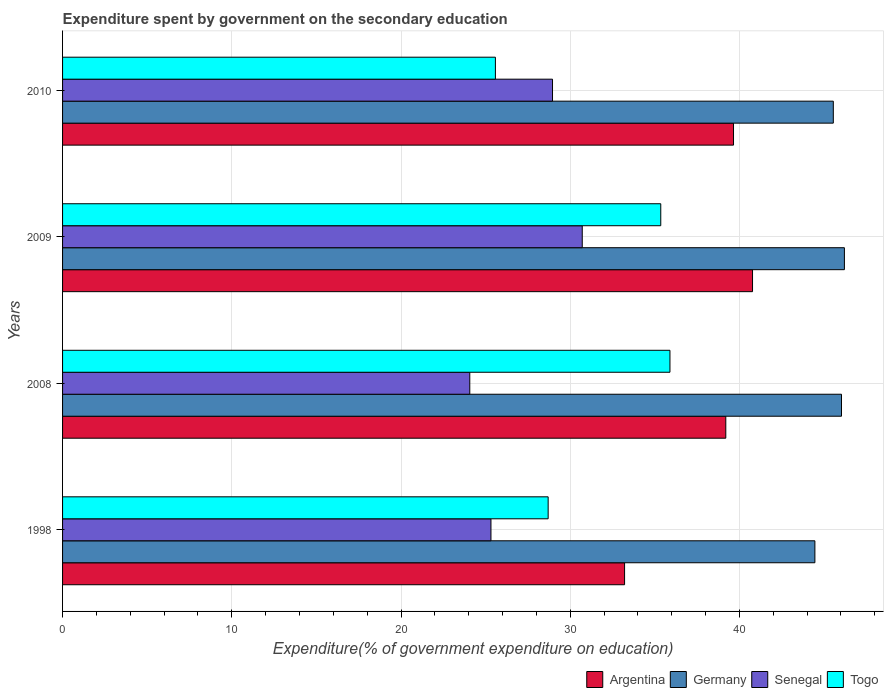Are the number of bars per tick equal to the number of legend labels?
Offer a very short reply. Yes. Are the number of bars on each tick of the Y-axis equal?
Offer a terse response. Yes. How many bars are there on the 3rd tick from the bottom?
Your response must be concise. 4. What is the label of the 2nd group of bars from the top?
Your answer should be very brief. 2009. What is the expenditure spent by government on the secondary education in Germany in 2009?
Your answer should be very brief. 46.2. Across all years, what is the maximum expenditure spent by government on the secondary education in Senegal?
Offer a very short reply. 30.71. Across all years, what is the minimum expenditure spent by government on the secondary education in Argentina?
Provide a succinct answer. 33.21. In which year was the expenditure spent by government on the secondary education in Togo maximum?
Provide a succinct answer. 2008. What is the total expenditure spent by government on the secondary education in Germany in the graph?
Make the answer very short. 182.24. What is the difference between the expenditure spent by government on the secondary education in Germany in 1998 and that in 2009?
Give a very brief answer. -1.74. What is the difference between the expenditure spent by government on the secondary education in Germany in 2009 and the expenditure spent by government on the secondary education in Togo in 1998?
Ensure brevity in your answer.  17.51. What is the average expenditure spent by government on the secondary education in Togo per year?
Give a very brief answer. 31.38. In the year 2009, what is the difference between the expenditure spent by government on the secondary education in Togo and expenditure spent by government on the secondary education in Argentina?
Offer a very short reply. -5.42. What is the ratio of the expenditure spent by government on the secondary education in Germany in 2008 to that in 2010?
Provide a succinct answer. 1.01. Is the expenditure spent by government on the secondary education in Germany in 2008 less than that in 2009?
Offer a very short reply. Yes. Is the difference between the expenditure spent by government on the secondary education in Togo in 2008 and 2010 greater than the difference between the expenditure spent by government on the secondary education in Argentina in 2008 and 2010?
Your response must be concise. Yes. What is the difference between the highest and the second highest expenditure spent by government on the secondary education in Argentina?
Keep it short and to the point. 1.12. What is the difference between the highest and the lowest expenditure spent by government on the secondary education in Argentina?
Offer a terse response. 7.56. In how many years, is the expenditure spent by government on the secondary education in Togo greater than the average expenditure spent by government on the secondary education in Togo taken over all years?
Give a very brief answer. 2. Is the sum of the expenditure spent by government on the secondary education in Germany in 1998 and 2009 greater than the maximum expenditure spent by government on the secondary education in Senegal across all years?
Provide a short and direct response. Yes. What does the 2nd bar from the top in 1998 represents?
Your answer should be very brief. Senegal. Is it the case that in every year, the sum of the expenditure spent by government on the secondary education in Togo and expenditure spent by government on the secondary education in Senegal is greater than the expenditure spent by government on the secondary education in Argentina?
Give a very brief answer. Yes. Are all the bars in the graph horizontal?
Your answer should be compact. Yes. How many years are there in the graph?
Make the answer very short. 4. How many legend labels are there?
Offer a very short reply. 4. How are the legend labels stacked?
Give a very brief answer. Horizontal. What is the title of the graph?
Offer a very short reply. Expenditure spent by government on the secondary education. Does "Japan" appear as one of the legend labels in the graph?
Give a very brief answer. No. What is the label or title of the X-axis?
Offer a very short reply. Expenditure(% of government expenditure on education). What is the Expenditure(% of government expenditure on education) of Argentina in 1998?
Provide a succinct answer. 33.21. What is the Expenditure(% of government expenditure on education) of Germany in 1998?
Offer a terse response. 44.46. What is the Expenditure(% of government expenditure on education) of Senegal in 1998?
Your answer should be compact. 25.32. What is the Expenditure(% of government expenditure on education) of Togo in 1998?
Provide a short and direct response. 28.7. What is the Expenditure(% of government expenditure on education) of Argentina in 2008?
Ensure brevity in your answer.  39.19. What is the Expenditure(% of government expenditure on education) of Germany in 2008?
Offer a terse response. 46.03. What is the Expenditure(% of government expenditure on education) in Senegal in 2008?
Give a very brief answer. 24.06. What is the Expenditure(% of government expenditure on education) in Togo in 2008?
Provide a short and direct response. 35.89. What is the Expenditure(% of government expenditure on education) of Argentina in 2009?
Ensure brevity in your answer.  40.77. What is the Expenditure(% of government expenditure on education) of Germany in 2009?
Give a very brief answer. 46.2. What is the Expenditure(% of government expenditure on education) of Senegal in 2009?
Ensure brevity in your answer.  30.71. What is the Expenditure(% of government expenditure on education) in Togo in 2009?
Offer a very short reply. 35.35. What is the Expenditure(% of government expenditure on education) of Argentina in 2010?
Keep it short and to the point. 39.65. What is the Expenditure(% of government expenditure on education) in Germany in 2010?
Give a very brief answer. 45.55. What is the Expenditure(% of government expenditure on education) in Senegal in 2010?
Your answer should be compact. 28.95. What is the Expenditure(% of government expenditure on education) in Togo in 2010?
Ensure brevity in your answer.  25.58. Across all years, what is the maximum Expenditure(% of government expenditure on education) of Argentina?
Offer a terse response. 40.77. Across all years, what is the maximum Expenditure(% of government expenditure on education) in Germany?
Give a very brief answer. 46.2. Across all years, what is the maximum Expenditure(% of government expenditure on education) in Senegal?
Ensure brevity in your answer.  30.71. Across all years, what is the maximum Expenditure(% of government expenditure on education) of Togo?
Provide a succinct answer. 35.89. Across all years, what is the minimum Expenditure(% of government expenditure on education) in Argentina?
Your answer should be very brief. 33.21. Across all years, what is the minimum Expenditure(% of government expenditure on education) in Germany?
Your response must be concise. 44.46. Across all years, what is the minimum Expenditure(% of government expenditure on education) in Senegal?
Keep it short and to the point. 24.06. Across all years, what is the minimum Expenditure(% of government expenditure on education) in Togo?
Offer a terse response. 25.58. What is the total Expenditure(% of government expenditure on education) of Argentina in the graph?
Make the answer very short. 152.83. What is the total Expenditure(% of government expenditure on education) of Germany in the graph?
Your answer should be very brief. 182.24. What is the total Expenditure(% of government expenditure on education) of Senegal in the graph?
Give a very brief answer. 109.04. What is the total Expenditure(% of government expenditure on education) in Togo in the graph?
Provide a short and direct response. 125.52. What is the difference between the Expenditure(% of government expenditure on education) in Argentina in 1998 and that in 2008?
Your response must be concise. -5.98. What is the difference between the Expenditure(% of government expenditure on education) of Germany in 1998 and that in 2008?
Offer a very short reply. -1.57. What is the difference between the Expenditure(% of government expenditure on education) of Senegal in 1998 and that in 2008?
Offer a terse response. 1.25. What is the difference between the Expenditure(% of government expenditure on education) in Togo in 1998 and that in 2008?
Offer a very short reply. -7.2. What is the difference between the Expenditure(% of government expenditure on education) in Argentina in 1998 and that in 2009?
Offer a terse response. -7.56. What is the difference between the Expenditure(% of government expenditure on education) of Germany in 1998 and that in 2009?
Offer a very short reply. -1.74. What is the difference between the Expenditure(% of government expenditure on education) of Senegal in 1998 and that in 2009?
Keep it short and to the point. -5.4. What is the difference between the Expenditure(% of government expenditure on education) of Togo in 1998 and that in 2009?
Give a very brief answer. -6.65. What is the difference between the Expenditure(% of government expenditure on education) of Argentina in 1998 and that in 2010?
Your response must be concise. -6.44. What is the difference between the Expenditure(% of government expenditure on education) of Germany in 1998 and that in 2010?
Give a very brief answer. -1.09. What is the difference between the Expenditure(% of government expenditure on education) of Senegal in 1998 and that in 2010?
Make the answer very short. -3.64. What is the difference between the Expenditure(% of government expenditure on education) of Togo in 1998 and that in 2010?
Your response must be concise. 3.12. What is the difference between the Expenditure(% of government expenditure on education) of Argentina in 2008 and that in 2009?
Make the answer very short. -1.58. What is the difference between the Expenditure(% of government expenditure on education) in Germany in 2008 and that in 2009?
Your response must be concise. -0.17. What is the difference between the Expenditure(% of government expenditure on education) of Senegal in 2008 and that in 2009?
Your answer should be compact. -6.65. What is the difference between the Expenditure(% of government expenditure on education) in Togo in 2008 and that in 2009?
Provide a short and direct response. 0.54. What is the difference between the Expenditure(% of government expenditure on education) of Argentina in 2008 and that in 2010?
Your answer should be very brief. -0.46. What is the difference between the Expenditure(% of government expenditure on education) of Germany in 2008 and that in 2010?
Your answer should be very brief. 0.48. What is the difference between the Expenditure(% of government expenditure on education) of Senegal in 2008 and that in 2010?
Provide a short and direct response. -4.89. What is the difference between the Expenditure(% of government expenditure on education) in Togo in 2008 and that in 2010?
Your answer should be very brief. 10.31. What is the difference between the Expenditure(% of government expenditure on education) of Argentina in 2009 and that in 2010?
Your response must be concise. 1.12. What is the difference between the Expenditure(% of government expenditure on education) in Germany in 2009 and that in 2010?
Your response must be concise. 0.66. What is the difference between the Expenditure(% of government expenditure on education) in Senegal in 2009 and that in 2010?
Offer a very short reply. 1.76. What is the difference between the Expenditure(% of government expenditure on education) in Togo in 2009 and that in 2010?
Ensure brevity in your answer.  9.77. What is the difference between the Expenditure(% of government expenditure on education) in Argentina in 1998 and the Expenditure(% of government expenditure on education) in Germany in 2008?
Keep it short and to the point. -12.82. What is the difference between the Expenditure(% of government expenditure on education) in Argentina in 1998 and the Expenditure(% of government expenditure on education) in Senegal in 2008?
Make the answer very short. 9.15. What is the difference between the Expenditure(% of government expenditure on education) in Argentina in 1998 and the Expenditure(% of government expenditure on education) in Togo in 2008?
Your response must be concise. -2.68. What is the difference between the Expenditure(% of government expenditure on education) of Germany in 1998 and the Expenditure(% of government expenditure on education) of Senegal in 2008?
Give a very brief answer. 20.39. What is the difference between the Expenditure(% of government expenditure on education) in Germany in 1998 and the Expenditure(% of government expenditure on education) in Togo in 2008?
Provide a succinct answer. 8.57. What is the difference between the Expenditure(% of government expenditure on education) of Senegal in 1998 and the Expenditure(% of government expenditure on education) of Togo in 2008?
Provide a succinct answer. -10.58. What is the difference between the Expenditure(% of government expenditure on education) in Argentina in 1998 and the Expenditure(% of government expenditure on education) in Germany in 2009?
Ensure brevity in your answer.  -12.99. What is the difference between the Expenditure(% of government expenditure on education) in Argentina in 1998 and the Expenditure(% of government expenditure on education) in Senegal in 2009?
Your answer should be compact. 2.5. What is the difference between the Expenditure(% of government expenditure on education) of Argentina in 1998 and the Expenditure(% of government expenditure on education) of Togo in 2009?
Your response must be concise. -2.14. What is the difference between the Expenditure(% of government expenditure on education) in Germany in 1998 and the Expenditure(% of government expenditure on education) in Senegal in 2009?
Provide a succinct answer. 13.75. What is the difference between the Expenditure(% of government expenditure on education) in Germany in 1998 and the Expenditure(% of government expenditure on education) in Togo in 2009?
Your answer should be very brief. 9.11. What is the difference between the Expenditure(% of government expenditure on education) in Senegal in 1998 and the Expenditure(% of government expenditure on education) in Togo in 2009?
Ensure brevity in your answer.  -10.04. What is the difference between the Expenditure(% of government expenditure on education) of Argentina in 1998 and the Expenditure(% of government expenditure on education) of Germany in 2010?
Make the answer very short. -12.34. What is the difference between the Expenditure(% of government expenditure on education) in Argentina in 1998 and the Expenditure(% of government expenditure on education) in Senegal in 2010?
Keep it short and to the point. 4.26. What is the difference between the Expenditure(% of government expenditure on education) of Argentina in 1998 and the Expenditure(% of government expenditure on education) of Togo in 2010?
Offer a very short reply. 7.63. What is the difference between the Expenditure(% of government expenditure on education) of Germany in 1998 and the Expenditure(% of government expenditure on education) of Senegal in 2010?
Provide a short and direct response. 15.51. What is the difference between the Expenditure(% of government expenditure on education) of Germany in 1998 and the Expenditure(% of government expenditure on education) of Togo in 2010?
Your response must be concise. 18.88. What is the difference between the Expenditure(% of government expenditure on education) in Senegal in 1998 and the Expenditure(% of government expenditure on education) in Togo in 2010?
Keep it short and to the point. -0.26. What is the difference between the Expenditure(% of government expenditure on education) of Argentina in 2008 and the Expenditure(% of government expenditure on education) of Germany in 2009?
Your answer should be compact. -7.01. What is the difference between the Expenditure(% of government expenditure on education) of Argentina in 2008 and the Expenditure(% of government expenditure on education) of Senegal in 2009?
Ensure brevity in your answer.  8.48. What is the difference between the Expenditure(% of government expenditure on education) of Argentina in 2008 and the Expenditure(% of government expenditure on education) of Togo in 2009?
Keep it short and to the point. 3.84. What is the difference between the Expenditure(% of government expenditure on education) in Germany in 2008 and the Expenditure(% of government expenditure on education) in Senegal in 2009?
Keep it short and to the point. 15.32. What is the difference between the Expenditure(% of government expenditure on education) in Germany in 2008 and the Expenditure(% of government expenditure on education) in Togo in 2009?
Your answer should be compact. 10.68. What is the difference between the Expenditure(% of government expenditure on education) of Senegal in 2008 and the Expenditure(% of government expenditure on education) of Togo in 2009?
Make the answer very short. -11.29. What is the difference between the Expenditure(% of government expenditure on education) in Argentina in 2008 and the Expenditure(% of government expenditure on education) in Germany in 2010?
Ensure brevity in your answer.  -6.35. What is the difference between the Expenditure(% of government expenditure on education) of Argentina in 2008 and the Expenditure(% of government expenditure on education) of Senegal in 2010?
Provide a short and direct response. 10.24. What is the difference between the Expenditure(% of government expenditure on education) of Argentina in 2008 and the Expenditure(% of government expenditure on education) of Togo in 2010?
Offer a very short reply. 13.61. What is the difference between the Expenditure(% of government expenditure on education) of Germany in 2008 and the Expenditure(% of government expenditure on education) of Senegal in 2010?
Your answer should be very brief. 17.08. What is the difference between the Expenditure(% of government expenditure on education) of Germany in 2008 and the Expenditure(% of government expenditure on education) of Togo in 2010?
Provide a succinct answer. 20.45. What is the difference between the Expenditure(% of government expenditure on education) of Senegal in 2008 and the Expenditure(% of government expenditure on education) of Togo in 2010?
Provide a succinct answer. -1.51. What is the difference between the Expenditure(% of government expenditure on education) of Argentina in 2009 and the Expenditure(% of government expenditure on education) of Germany in 2010?
Provide a succinct answer. -4.77. What is the difference between the Expenditure(% of government expenditure on education) of Argentina in 2009 and the Expenditure(% of government expenditure on education) of Senegal in 2010?
Make the answer very short. 11.82. What is the difference between the Expenditure(% of government expenditure on education) of Argentina in 2009 and the Expenditure(% of government expenditure on education) of Togo in 2010?
Offer a very short reply. 15.19. What is the difference between the Expenditure(% of government expenditure on education) in Germany in 2009 and the Expenditure(% of government expenditure on education) in Senegal in 2010?
Your answer should be compact. 17.25. What is the difference between the Expenditure(% of government expenditure on education) of Germany in 2009 and the Expenditure(% of government expenditure on education) of Togo in 2010?
Your answer should be very brief. 20.62. What is the difference between the Expenditure(% of government expenditure on education) in Senegal in 2009 and the Expenditure(% of government expenditure on education) in Togo in 2010?
Offer a very short reply. 5.13. What is the average Expenditure(% of government expenditure on education) in Argentina per year?
Offer a very short reply. 38.21. What is the average Expenditure(% of government expenditure on education) of Germany per year?
Provide a short and direct response. 45.56. What is the average Expenditure(% of government expenditure on education) in Senegal per year?
Keep it short and to the point. 27.26. What is the average Expenditure(% of government expenditure on education) in Togo per year?
Give a very brief answer. 31.38. In the year 1998, what is the difference between the Expenditure(% of government expenditure on education) of Argentina and Expenditure(% of government expenditure on education) of Germany?
Your answer should be compact. -11.25. In the year 1998, what is the difference between the Expenditure(% of government expenditure on education) in Argentina and Expenditure(% of government expenditure on education) in Senegal?
Provide a succinct answer. 7.9. In the year 1998, what is the difference between the Expenditure(% of government expenditure on education) of Argentina and Expenditure(% of government expenditure on education) of Togo?
Your answer should be compact. 4.52. In the year 1998, what is the difference between the Expenditure(% of government expenditure on education) in Germany and Expenditure(% of government expenditure on education) in Senegal?
Offer a terse response. 19.14. In the year 1998, what is the difference between the Expenditure(% of government expenditure on education) of Germany and Expenditure(% of government expenditure on education) of Togo?
Your response must be concise. 15.76. In the year 1998, what is the difference between the Expenditure(% of government expenditure on education) in Senegal and Expenditure(% of government expenditure on education) in Togo?
Give a very brief answer. -3.38. In the year 2008, what is the difference between the Expenditure(% of government expenditure on education) in Argentina and Expenditure(% of government expenditure on education) in Germany?
Your answer should be compact. -6.84. In the year 2008, what is the difference between the Expenditure(% of government expenditure on education) in Argentina and Expenditure(% of government expenditure on education) in Senegal?
Provide a succinct answer. 15.13. In the year 2008, what is the difference between the Expenditure(% of government expenditure on education) in Argentina and Expenditure(% of government expenditure on education) in Togo?
Offer a terse response. 3.3. In the year 2008, what is the difference between the Expenditure(% of government expenditure on education) of Germany and Expenditure(% of government expenditure on education) of Senegal?
Make the answer very short. 21.97. In the year 2008, what is the difference between the Expenditure(% of government expenditure on education) in Germany and Expenditure(% of government expenditure on education) in Togo?
Give a very brief answer. 10.14. In the year 2008, what is the difference between the Expenditure(% of government expenditure on education) of Senegal and Expenditure(% of government expenditure on education) of Togo?
Give a very brief answer. -11.83. In the year 2009, what is the difference between the Expenditure(% of government expenditure on education) in Argentina and Expenditure(% of government expenditure on education) in Germany?
Offer a terse response. -5.43. In the year 2009, what is the difference between the Expenditure(% of government expenditure on education) of Argentina and Expenditure(% of government expenditure on education) of Senegal?
Your answer should be compact. 10.06. In the year 2009, what is the difference between the Expenditure(% of government expenditure on education) in Argentina and Expenditure(% of government expenditure on education) in Togo?
Offer a very short reply. 5.42. In the year 2009, what is the difference between the Expenditure(% of government expenditure on education) of Germany and Expenditure(% of government expenditure on education) of Senegal?
Give a very brief answer. 15.49. In the year 2009, what is the difference between the Expenditure(% of government expenditure on education) in Germany and Expenditure(% of government expenditure on education) in Togo?
Your answer should be very brief. 10.85. In the year 2009, what is the difference between the Expenditure(% of government expenditure on education) of Senegal and Expenditure(% of government expenditure on education) of Togo?
Provide a succinct answer. -4.64. In the year 2010, what is the difference between the Expenditure(% of government expenditure on education) in Argentina and Expenditure(% of government expenditure on education) in Germany?
Ensure brevity in your answer.  -5.9. In the year 2010, what is the difference between the Expenditure(% of government expenditure on education) of Argentina and Expenditure(% of government expenditure on education) of Senegal?
Your answer should be very brief. 10.7. In the year 2010, what is the difference between the Expenditure(% of government expenditure on education) of Argentina and Expenditure(% of government expenditure on education) of Togo?
Your answer should be compact. 14.07. In the year 2010, what is the difference between the Expenditure(% of government expenditure on education) of Germany and Expenditure(% of government expenditure on education) of Senegal?
Your answer should be compact. 16.59. In the year 2010, what is the difference between the Expenditure(% of government expenditure on education) in Germany and Expenditure(% of government expenditure on education) in Togo?
Offer a terse response. 19.97. In the year 2010, what is the difference between the Expenditure(% of government expenditure on education) of Senegal and Expenditure(% of government expenditure on education) of Togo?
Give a very brief answer. 3.37. What is the ratio of the Expenditure(% of government expenditure on education) of Argentina in 1998 to that in 2008?
Your response must be concise. 0.85. What is the ratio of the Expenditure(% of government expenditure on education) in Germany in 1998 to that in 2008?
Your answer should be compact. 0.97. What is the ratio of the Expenditure(% of government expenditure on education) in Senegal in 1998 to that in 2008?
Your response must be concise. 1.05. What is the ratio of the Expenditure(% of government expenditure on education) in Togo in 1998 to that in 2008?
Provide a succinct answer. 0.8. What is the ratio of the Expenditure(% of government expenditure on education) of Argentina in 1998 to that in 2009?
Your response must be concise. 0.81. What is the ratio of the Expenditure(% of government expenditure on education) of Germany in 1998 to that in 2009?
Your response must be concise. 0.96. What is the ratio of the Expenditure(% of government expenditure on education) in Senegal in 1998 to that in 2009?
Offer a very short reply. 0.82. What is the ratio of the Expenditure(% of government expenditure on education) of Togo in 1998 to that in 2009?
Provide a succinct answer. 0.81. What is the ratio of the Expenditure(% of government expenditure on education) in Argentina in 1998 to that in 2010?
Ensure brevity in your answer.  0.84. What is the ratio of the Expenditure(% of government expenditure on education) of Germany in 1998 to that in 2010?
Offer a terse response. 0.98. What is the ratio of the Expenditure(% of government expenditure on education) of Senegal in 1998 to that in 2010?
Your response must be concise. 0.87. What is the ratio of the Expenditure(% of government expenditure on education) in Togo in 1998 to that in 2010?
Make the answer very short. 1.12. What is the ratio of the Expenditure(% of government expenditure on education) in Argentina in 2008 to that in 2009?
Provide a succinct answer. 0.96. What is the ratio of the Expenditure(% of government expenditure on education) in Senegal in 2008 to that in 2009?
Make the answer very short. 0.78. What is the ratio of the Expenditure(% of government expenditure on education) of Togo in 2008 to that in 2009?
Your response must be concise. 1.02. What is the ratio of the Expenditure(% of government expenditure on education) in Argentina in 2008 to that in 2010?
Your answer should be very brief. 0.99. What is the ratio of the Expenditure(% of government expenditure on education) of Germany in 2008 to that in 2010?
Offer a very short reply. 1.01. What is the ratio of the Expenditure(% of government expenditure on education) in Senegal in 2008 to that in 2010?
Ensure brevity in your answer.  0.83. What is the ratio of the Expenditure(% of government expenditure on education) in Togo in 2008 to that in 2010?
Offer a very short reply. 1.4. What is the ratio of the Expenditure(% of government expenditure on education) in Argentina in 2009 to that in 2010?
Your response must be concise. 1.03. What is the ratio of the Expenditure(% of government expenditure on education) in Germany in 2009 to that in 2010?
Ensure brevity in your answer.  1.01. What is the ratio of the Expenditure(% of government expenditure on education) in Senegal in 2009 to that in 2010?
Keep it short and to the point. 1.06. What is the ratio of the Expenditure(% of government expenditure on education) in Togo in 2009 to that in 2010?
Your answer should be compact. 1.38. What is the difference between the highest and the second highest Expenditure(% of government expenditure on education) in Argentina?
Offer a terse response. 1.12. What is the difference between the highest and the second highest Expenditure(% of government expenditure on education) of Germany?
Keep it short and to the point. 0.17. What is the difference between the highest and the second highest Expenditure(% of government expenditure on education) in Senegal?
Offer a very short reply. 1.76. What is the difference between the highest and the second highest Expenditure(% of government expenditure on education) in Togo?
Offer a terse response. 0.54. What is the difference between the highest and the lowest Expenditure(% of government expenditure on education) in Argentina?
Make the answer very short. 7.56. What is the difference between the highest and the lowest Expenditure(% of government expenditure on education) in Germany?
Your answer should be compact. 1.74. What is the difference between the highest and the lowest Expenditure(% of government expenditure on education) in Senegal?
Offer a terse response. 6.65. What is the difference between the highest and the lowest Expenditure(% of government expenditure on education) in Togo?
Offer a terse response. 10.31. 